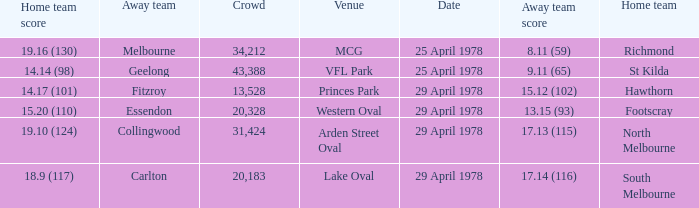Would you mind parsing the complete table? {'header': ['Home team score', 'Away team', 'Crowd', 'Venue', 'Date', 'Away team score', 'Home team'], 'rows': [['19.16 (130)', 'Melbourne', '34,212', 'MCG', '25 April 1978', '8.11 (59)', 'Richmond'], ['14.14 (98)', 'Geelong', '43,388', 'VFL Park', '25 April 1978', '9.11 (65)', 'St Kilda'], ['14.17 (101)', 'Fitzroy', '13,528', 'Princes Park', '29 April 1978', '15.12 (102)', 'Hawthorn'], ['15.20 (110)', 'Essendon', '20,328', 'Western Oval', '29 April 1978', '13.15 (93)', 'Footscray'], ['19.10 (124)', 'Collingwood', '31,424', 'Arden Street Oval', '29 April 1978', '17.13 (115)', 'North Melbourne'], ['18.9 (117)', 'Carlton', '20,183', 'Lake Oval', '29 April 1978', '17.14 (116)', 'South Melbourne']]} What was the away team that played at Princes Park? Fitzroy. 